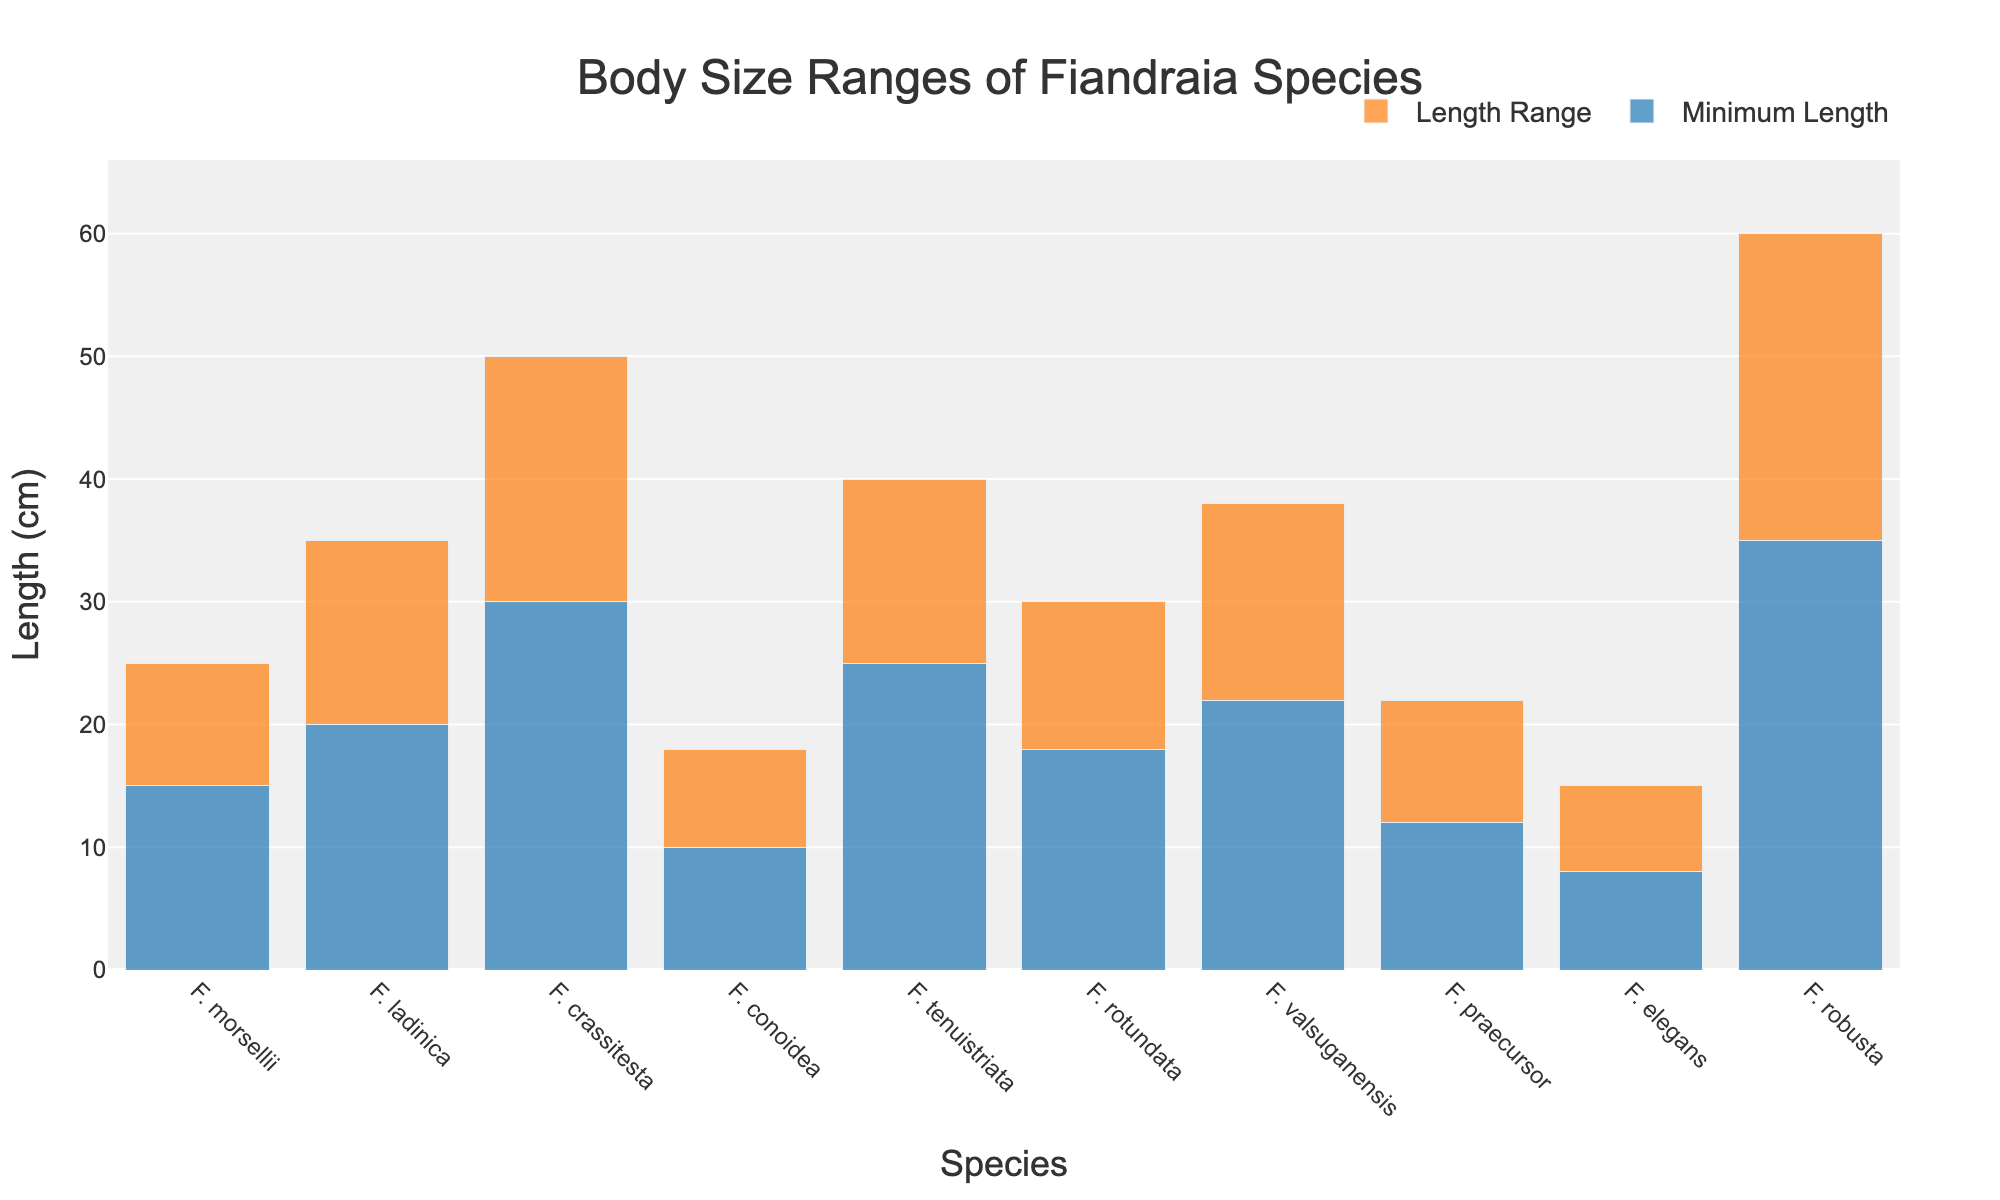What is the species with the smallest minimum length? The species with the smallest minimum length can be identified by locating the bar with the lowest base value for the "Minimum Length" segment. Fiandraia elegans has the minimum length of 8 cm.
Answer: Fiandraia elegans Which species has the largest range in body size? To find the species with the largest range, subtract the minimum length from the maximum length for each species and identify the maximum difference. Fiandraia robusta has a range of 25 cm (60 cm - 35 cm).
Answer: Fiandraia robusta What is the combined minimum length of Fiandraia morsellii and Fiandraia robusta? Add the minimum lengths of Fiandraia morsellii (15 cm) and Fiandraia robusta (35 cm). The sum is 15 + 35 = 50 cm.
Answer: 50 cm Which species has a maximum length that is less than 20 cm? Identify the species where the height of the "Length Range" segment, added to the "Minimum Length" segment, results in a maximum length less than 20 cm. Fiandraia conoidea (18 cm) and Fiandraia elegans (15 cm) have maximum lengths less than 20 cm.
Answer: Fiandraia conoidea, Fiandraia elegans Compare the maximum lengths of Fiandraia ladinica and Fiandraia tenuistriata. Which one is greater? The maximum length of Fiandraia ladinica is 35 cm, while Fiandraia tenuistriata is 40 cm. Since 40 cm is greater than 35 cm, Fiandraia tenuistriata has a greater maximum length.
Answer: Fiandraia tenuistriata What is the difference in maximum length between Fiandraia crassitesta and Fiandraia valsuganensis? Subtract the maximum length of Fiandraia valsuganensis (38 cm) from Fiandraia crassitesta (50 cm). The difference is 50 - 38 = 12 cm.
Answer: 12 cm How many species have a minimum length of 20 cm or more? Count the number of species where the base of the "Minimum Length" segment is 20 cm or more. There are 6 species: Fiandraia ladinica, Fiandraia crassitesta, Fiandraia tenuistriata, Fiandraia rotundata, Fiandraia valsuganensis, and Fiandraia robusta.
Answer: 6 What is the median of the maximum lengths? To find the median, list the maximum lengths in ascending order and find the middle value. The ordered lengths are: 15, 18, 22, 25, 30, 35, 38, 40, 50, 60. The middle values are 30 and 35, so the median is (30 + 35) / 2 = 32.5 cm.
Answer: 32.5 cm Which species has the longest minimum length of any species with a maximum length under 40 cm? Identify species with a maximum length under 40 cm and find the one with the longest minimum length. Fiandraia valsuganensis has a maximum length of 38 cm and a minimum length of 22 cm, the longest among species with maximum lengths under 40 cm.
Answer: Fiandraia valsuganensis What is the total length range for Fiandraia conoidea and Fiandraia praecursor combined? Calculate the range for each species (Fiandraia conoidea: 18 cm - 10 cm = 8 cm, Fiandraia praecursor: 22 cm - 12 cm = 10 cm), then add them together. The combined length range is 8 cm + 10 cm = 18 cm.
Answer: 18 cm 